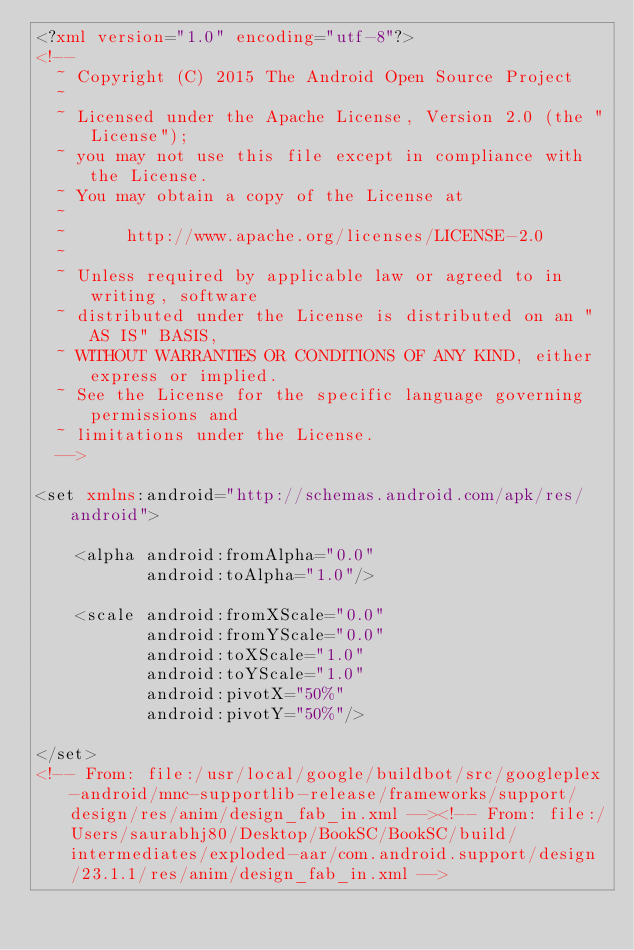Convert code to text. <code><loc_0><loc_0><loc_500><loc_500><_XML_><?xml version="1.0" encoding="utf-8"?>
<!--
  ~ Copyright (C) 2015 The Android Open Source Project
  ~
  ~ Licensed under the Apache License, Version 2.0 (the "License");
  ~ you may not use this file except in compliance with the License.
  ~ You may obtain a copy of the License at
  ~
  ~      http://www.apache.org/licenses/LICENSE-2.0
  ~
  ~ Unless required by applicable law or agreed to in writing, software
  ~ distributed under the License is distributed on an "AS IS" BASIS,
  ~ WITHOUT WARRANTIES OR CONDITIONS OF ANY KIND, either express or implied.
  ~ See the License for the specific language governing permissions and
  ~ limitations under the License.
  -->

<set xmlns:android="http://schemas.android.com/apk/res/android">

    <alpha android:fromAlpha="0.0"
           android:toAlpha="1.0"/>

    <scale android:fromXScale="0.0"
           android:fromYScale="0.0"
           android:toXScale="1.0"
           android:toYScale="1.0"
           android:pivotX="50%"
           android:pivotY="50%"/>

</set>
<!-- From: file:/usr/local/google/buildbot/src/googleplex-android/mnc-supportlib-release/frameworks/support/design/res/anim/design_fab_in.xml --><!-- From: file:/Users/saurabhj80/Desktop/BookSC/BookSC/build/intermediates/exploded-aar/com.android.support/design/23.1.1/res/anim/design_fab_in.xml --></code> 